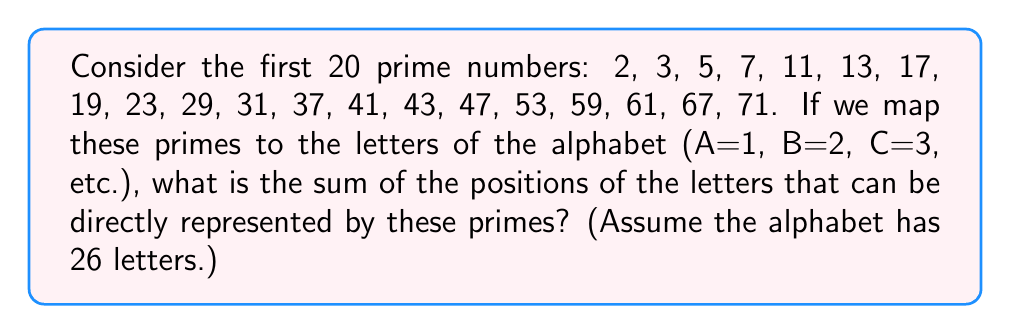What is the answer to this math problem? To solve this problem, we need to follow these steps:

1) First, let's identify which of the first 20 prime numbers correspond to letters in the alphabet:

   2 → B
   3 → C
   5 → E
   7 → G
   11 → K
   13 → M
   17 → Q
   19 → S
   23 → W

2) Now, we need to sum the positions of these letters in the alphabet:

   B is the 2nd letter
   C is the 3rd letter
   E is the 5th letter
   G is the 7th letter
   K is the 11th letter
   M is the 13th letter
   Q is the 17th letter
   S is the 19th letter
   W is the 23rd letter

3) Let's sum these positions:

   $$ 2 + 3 + 5 + 7 + 11 + 13 + 17 + 19 + 23 = 100 $$

This problem relates to the given topic and persona by connecting prime numbers to linguistic elements (letters), which could be used in analyzing patterns for potential linguistic applications in cryptolinguistics.
Answer: 100 